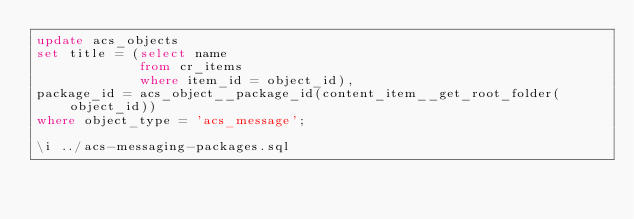Convert code to text. <code><loc_0><loc_0><loc_500><loc_500><_SQL_>update acs_objects
set title = (select name
             from cr_items
             where item_id = object_id),
package_id = acs_object__package_id(content_item__get_root_folder(object_id))
where object_type = 'acs_message';

\i ../acs-messaging-packages.sql
</code> 